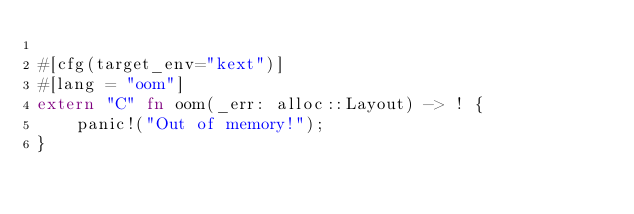<code> <loc_0><loc_0><loc_500><loc_500><_Rust_>
#[cfg(target_env="kext")]
#[lang = "oom"]
extern "C" fn oom(_err: alloc::Layout) -> ! {
    panic!("Out of memory!");
}
</code> 